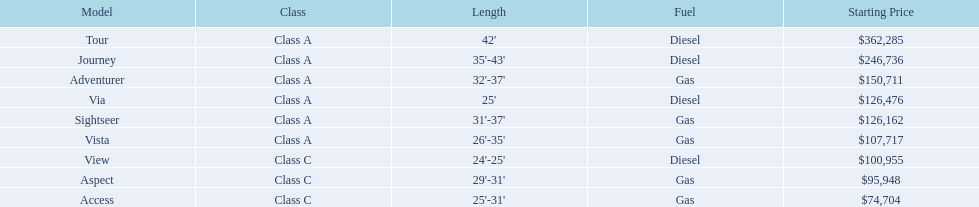Which model has the lowest starting price? Access. Which model has the second most highest starting price? Journey. Which model has the highest price in the winnebago industry? Tour. 